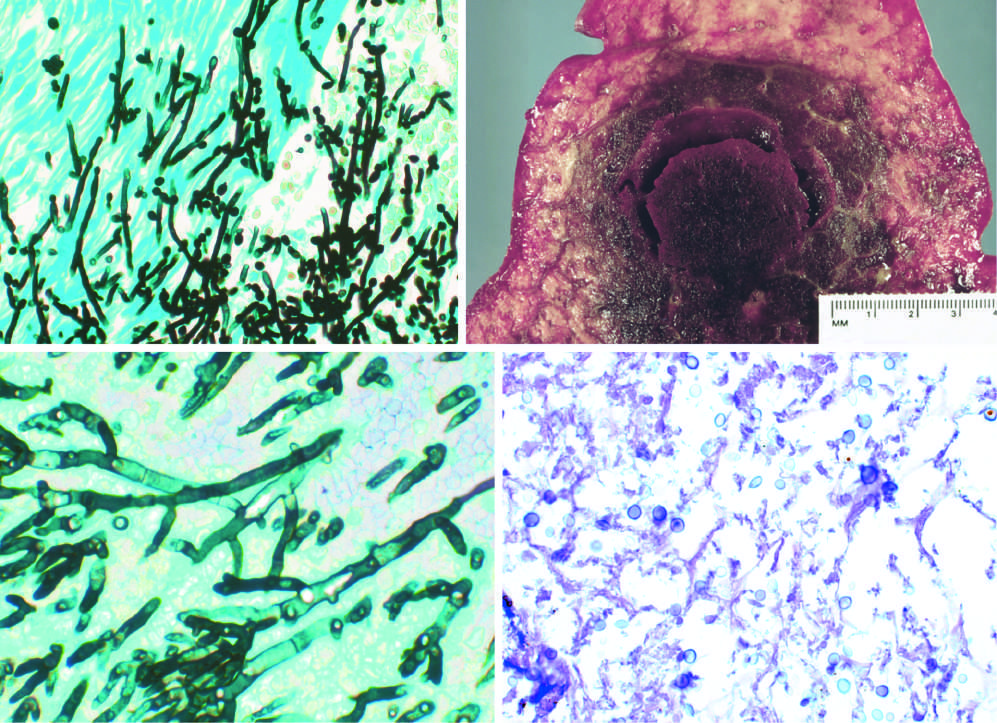what does gomori methenamine-silver (gms) stain show?
Answer the question using a single word or phrase. Septate hyphae with acute-angle branching 